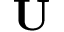Convert formula to latex. <formula><loc_0><loc_0><loc_500><loc_500>U</formula> 